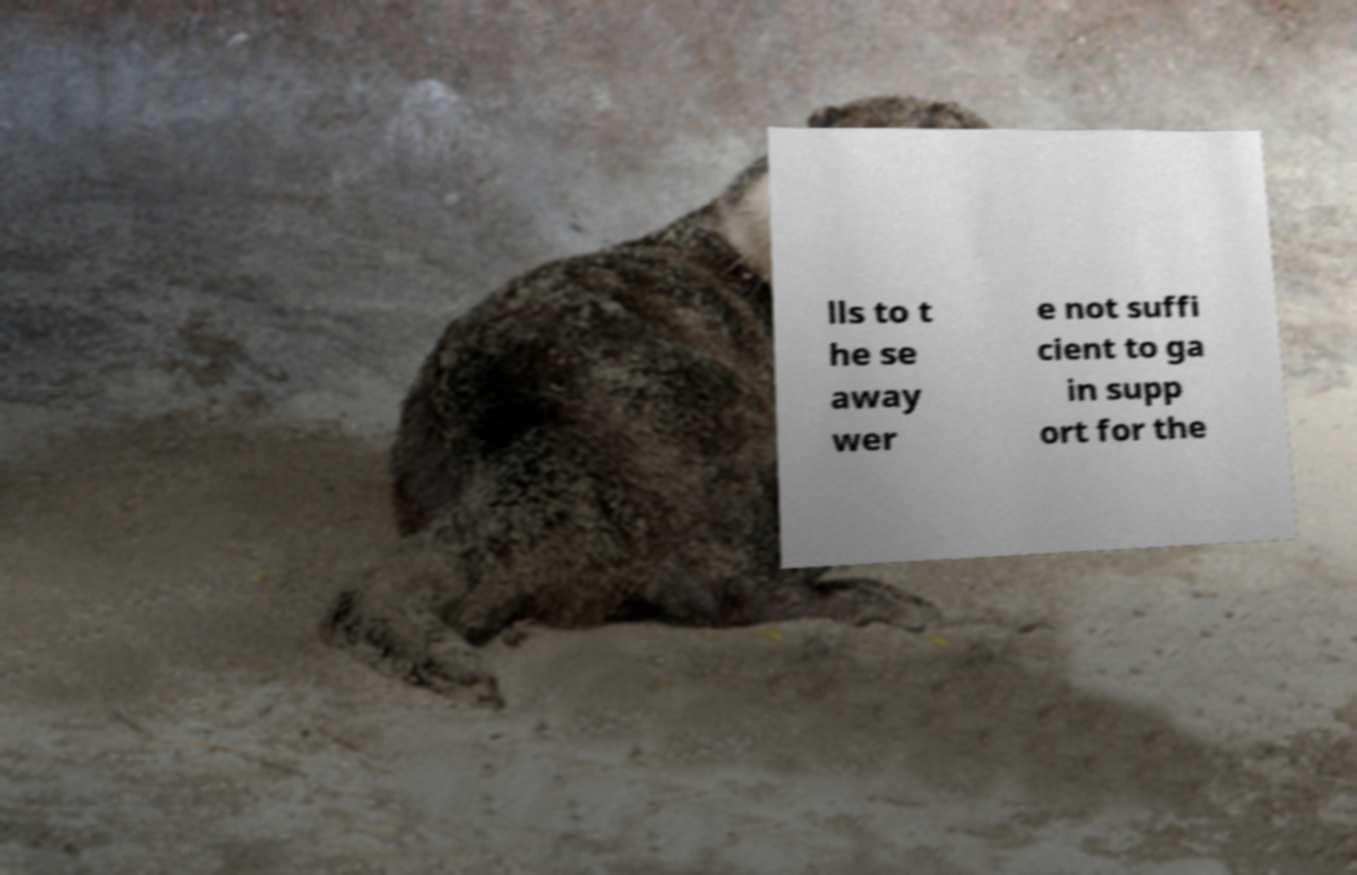Please identify and transcribe the text found in this image. lls to t he se away wer e not suffi cient to ga in supp ort for the 